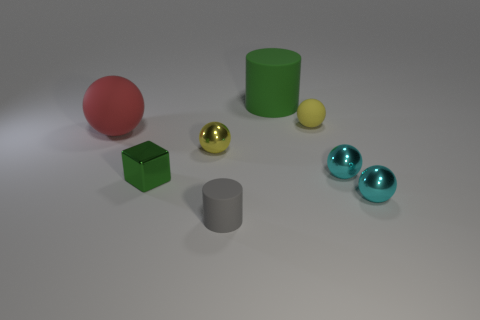What number of yellow things are large matte cylinders or tiny shiny spheres?
Offer a terse response. 1. What color is the big rubber sphere?
Keep it short and to the point. Red. Is the number of yellow balls that are on the right side of the green matte cylinder less than the number of tiny cyan objects that are on the right side of the small gray rubber cylinder?
Offer a very short reply. Yes. There is a small thing that is to the left of the large green cylinder and to the right of the small yellow shiny object; what is its shape?
Offer a terse response. Cylinder. How many small rubber objects have the same shape as the green shiny object?
Give a very brief answer. 0. There is a red ball that is made of the same material as the tiny cylinder; what is its size?
Give a very brief answer. Large. How many green things have the same size as the green matte cylinder?
Provide a succinct answer. 0. There is a cylinder that is the same color as the small block; what is its size?
Offer a terse response. Large. There is a cylinder that is to the left of the green thing that is behind the small yellow rubber sphere; what is its color?
Give a very brief answer. Gray. Is there a big rubber cylinder that has the same color as the tiny shiny block?
Provide a short and direct response. Yes. 